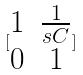<formula> <loc_0><loc_0><loc_500><loc_500>[ \begin{matrix} 1 & \frac { 1 } { s C } \\ 0 & 1 \end{matrix} ]</formula> 